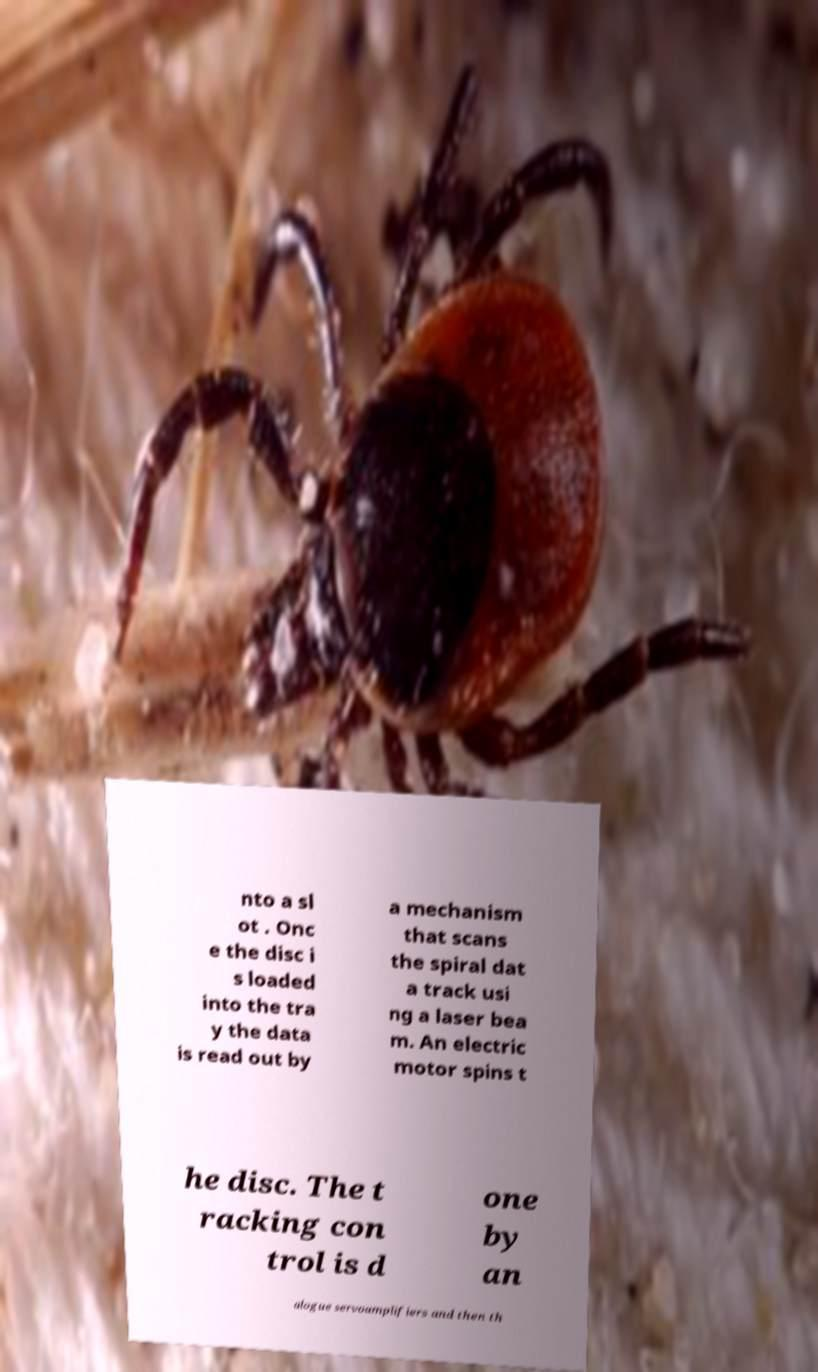Please identify and transcribe the text found in this image. nto a sl ot . Onc e the disc i s loaded into the tra y the data is read out by a mechanism that scans the spiral dat a track usi ng a laser bea m. An electric motor spins t he disc. The t racking con trol is d one by an alogue servoamplifiers and then th 